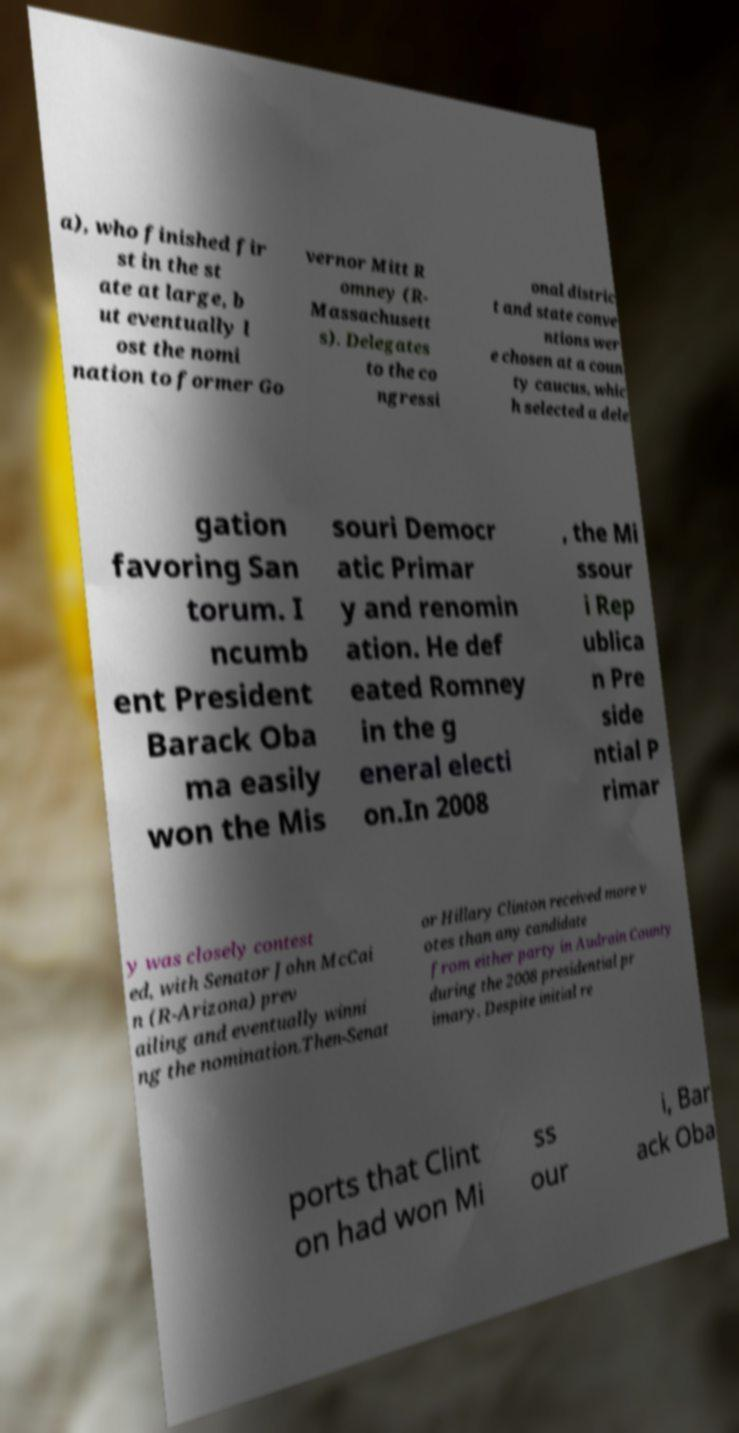Could you extract and type out the text from this image? a), who finished fir st in the st ate at large, b ut eventually l ost the nomi nation to former Go vernor Mitt R omney (R- Massachusett s). Delegates to the co ngressi onal distric t and state conve ntions wer e chosen at a coun ty caucus, whic h selected a dele gation favoring San torum. I ncumb ent President Barack Oba ma easily won the Mis souri Democr atic Primar y and renomin ation. He def eated Romney in the g eneral electi on.In 2008 , the Mi ssour i Rep ublica n Pre side ntial P rimar y was closely contest ed, with Senator John McCai n (R-Arizona) prev ailing and eventually winni ng the nomination.Then-Senat or Hillary Clinton received more v otes than any candidate from either party in Audrain County during the 2008 presidential pr imary. Despite initial re ports that Clint on had won Mi ss our i, Bar ack Oba 